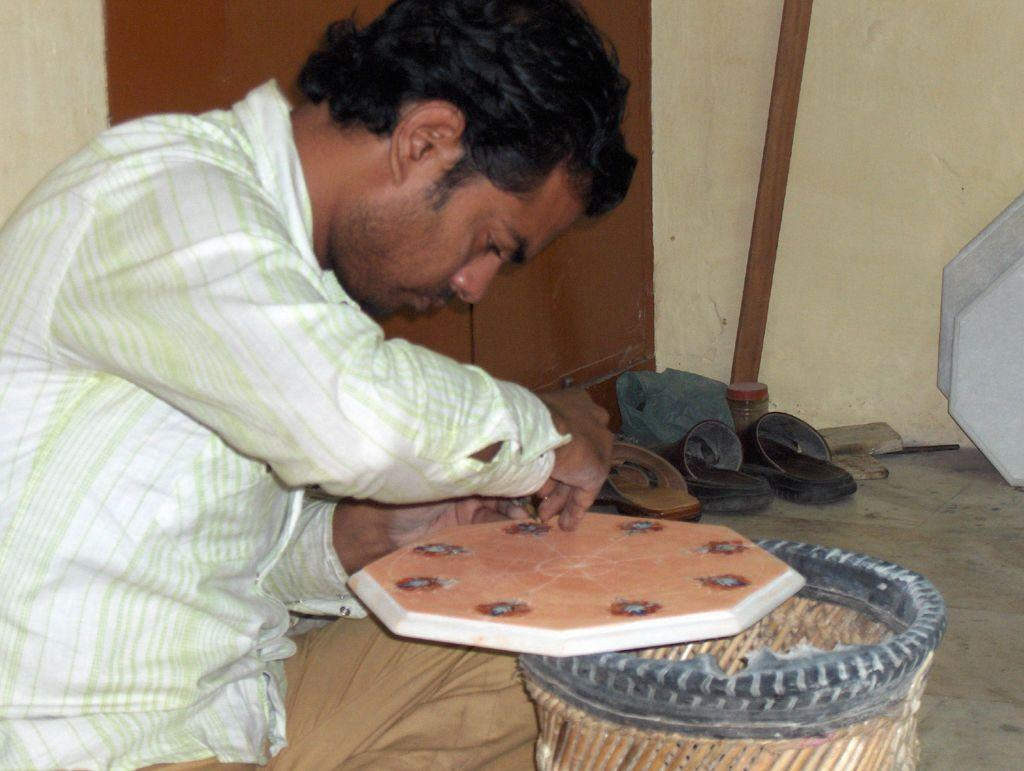What is the person in the image doing? The person is sitting and working on an object. What can be seen in the background of the image? There are foot-wears and a wooden stick in the background of the image. What type of hook can be seen hanging from the person's neck in the image? There is no hook visible in the image; the person is simply sitting and working on an object. 